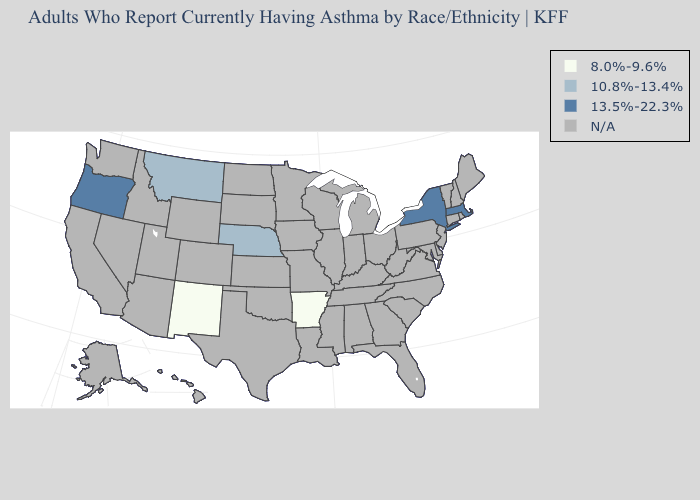Which states hav the highest value in the West?
Concise answer only. Oregon. What is the value of Mississippi?
Keep it brief. N/A. Name the states that have a value in the range 13.5%-22.3%?
Answer briefly. Massachusetts, New York, Oregon. Name the states that have a value in the range N/A?
Quick response, please. Alabama, Alaska, Arizona, California, Colorado, Connecticut, Delaware, Florida, Georgia, Hawaii, Idaho, Illinois, Indiana, Iowa, Kansas, Kentucky, Louisiana, Maine, Maryland, Michigan, Minnesota, Mississippi, Missouri, Nevada, New Hampshire, New Jersey, North Carolina, North Dakota, Ohio, Oklahoma, Pennsylvania, Rhode Island, South Carolina, South Dakota, Tennessee, Texas, Utah, Vermont, Virginia, Washington, West Virginia, Wisconsin, Wyoming. Does New Mexico have the lowest value in the West?
Answer briefly. Yes. What is the value of Pennsylvania?
Concise answer only. N/A. What is the value of Tennessee?
Answer briefly. N/A. What is the value of Ohio?
Concise answer only. N/A. Which states have the lowest value in the South?
Write a very short answer. Arkansas. 